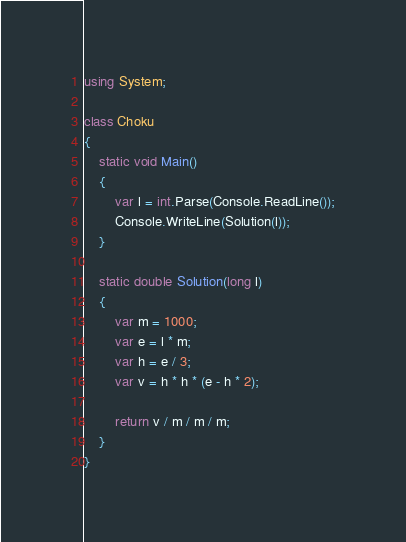Convert code to text. <code><loc_0><loc_0><loc_500><loc_500><_C#_>using System;

class Choku
{
    static void Main()
    {
        var l = int.Parse(Console.ReadLine());
        Console.WriteLine(Solution(l));
    }

    static double Solution(long l)
    {
        var m = 1000;
        var e = l * m;
        var h = e / 3;
        var v = h * h * (e - h * 2);

        return v / m / m / m;
    }
}</code> 